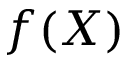<formula> <loc_0><loc_0><loc_500><loc_500>f ( X )</formula> 